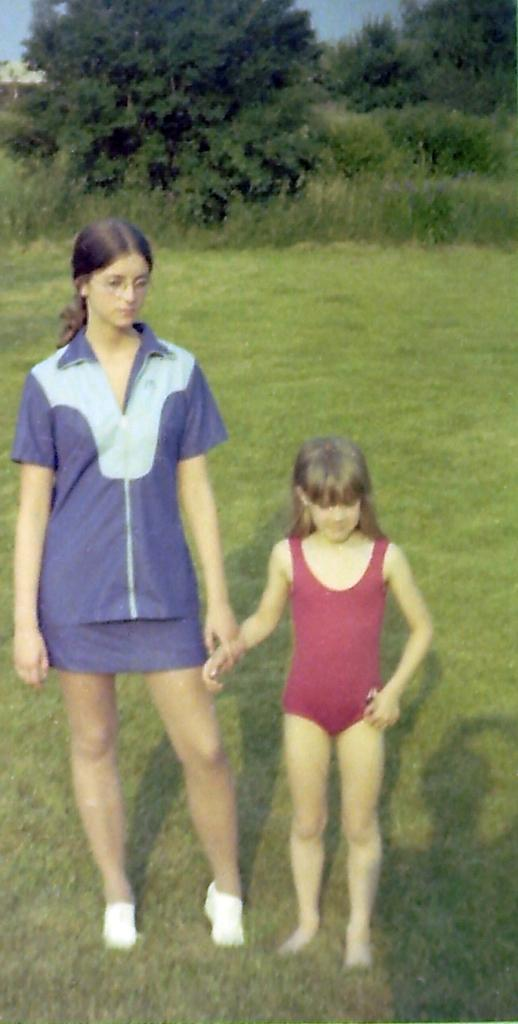What is the main subject of the image? The main subject of the image is children standing on the ground. What can be seen in the background of the image? There are trees in the background of the image. What is visible in the sky in the image? The sky is visible in the background of the image. What type of scent can be smelled coming from the flowers in the image? There are no flowers present in the image, so it is not possible to determine what scent might be smelled. 